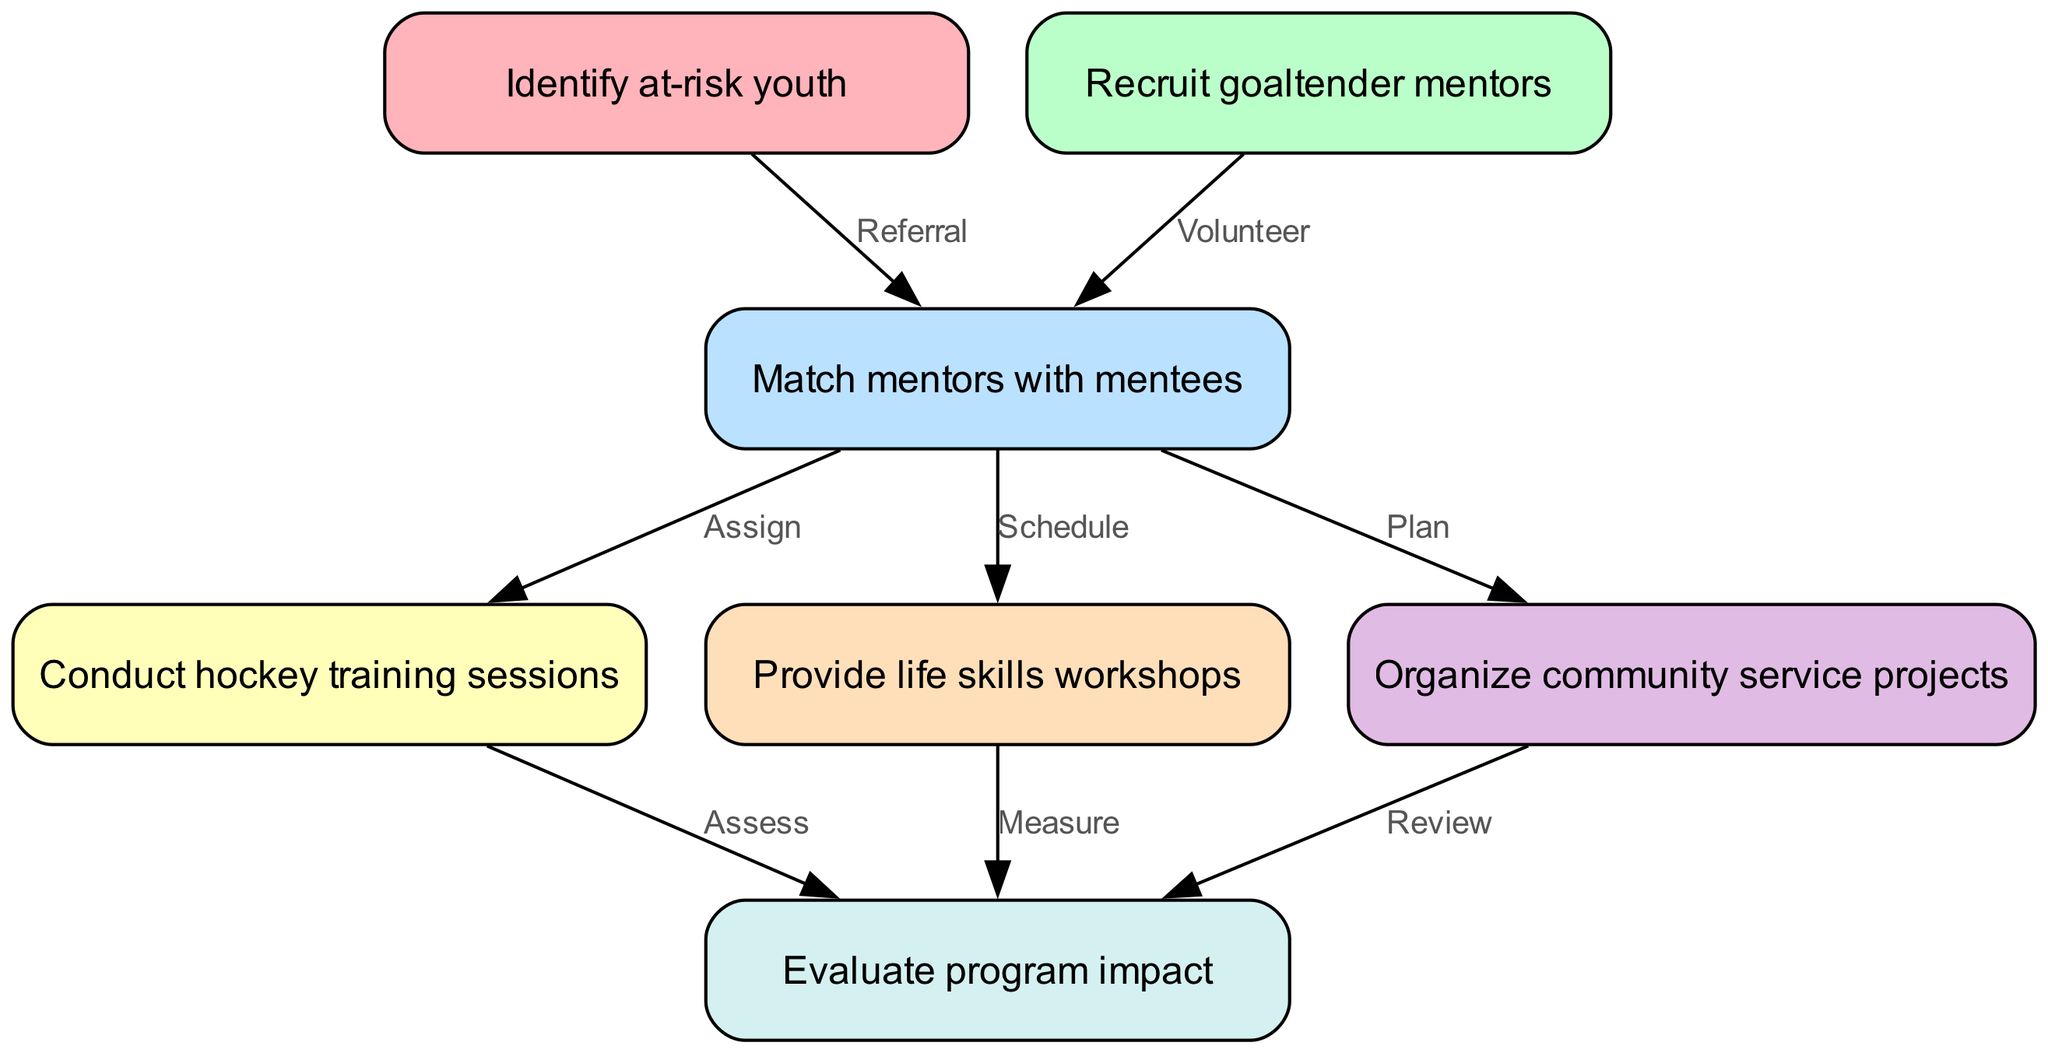What is the first step in the youth mentorship initiative workflow? The first step is to "Identify at-risk youth." This is the initial action that starts the workflow leading towards mentorship.
Answer: Identify at-risk youth How many nodes are present in the diagram? There are seven nodes in the diagram, each representing a different step in the mentorship initiative workflow.
Answer: 7 What type of connection exists between "Recruit goaltender mentors" and "Match mentors with mentees"? The connection is labeled "Volunteer," indicating that goaltender mentors are recruited through this process to become mentors for at-risk youth.
Answer: Volunteer What are the three actions that occur after matching mentors with mentees? After matching, the actions are "Conduct hockey training sessions," "Provide life skills workshops," and "Organize community service projects." These represent the practical engagement in mentorship.
Answer: Conduct hockey training sessions, Provide life skills workshops, Organize community service projects Which node is evaluated for its impact at the end of the process? The node that is evaluated for program impact is "Evaluate program impact." This indicates a review of the effectiveness of the initiatives that have taken place through the mentorship program.
Answer: Evaluate program impact What label does the edge between "Conduct hockey training sessions" and "Evaluate program impact" carry? The label on the edge is "Assess," which specifies the action of assessing the outcomes of the hockey training sessions in relation to the overall program impact.
Answer: Assess What is required to connect "Identify at-risk youth" to "Match mentors with mentees"? A referral is required to connect these two nodes, meaning that identifying at-risk youth leads to their recommendation for mentorship matching.
Answer: Referral Which two activities must be scheduled alongside mentoring? The activities that must be scheduled alongside mentoring are "Provide life skills workshops" and "Conduct hockey training sessions," both essential to the holistic development facilitated by the initiative.
Answer: Provide life skills workshops, Conduct hockey training sessions 